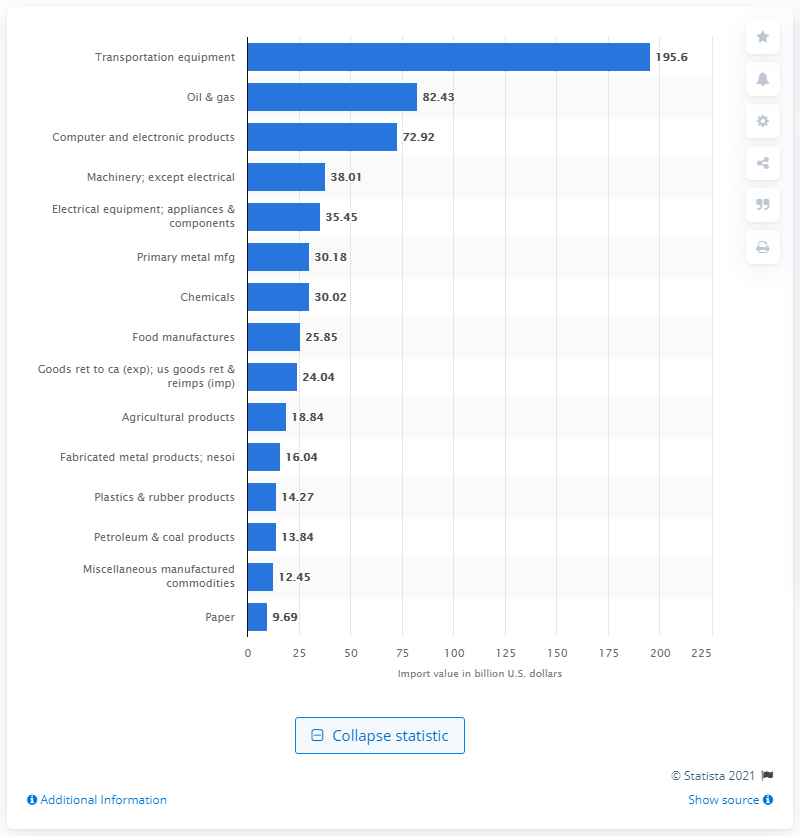Mention a couple of crucial points in this snapshot. In 2019, a total of 82.43 million barrels of oil and gas were imported from NAFTA member countries. 